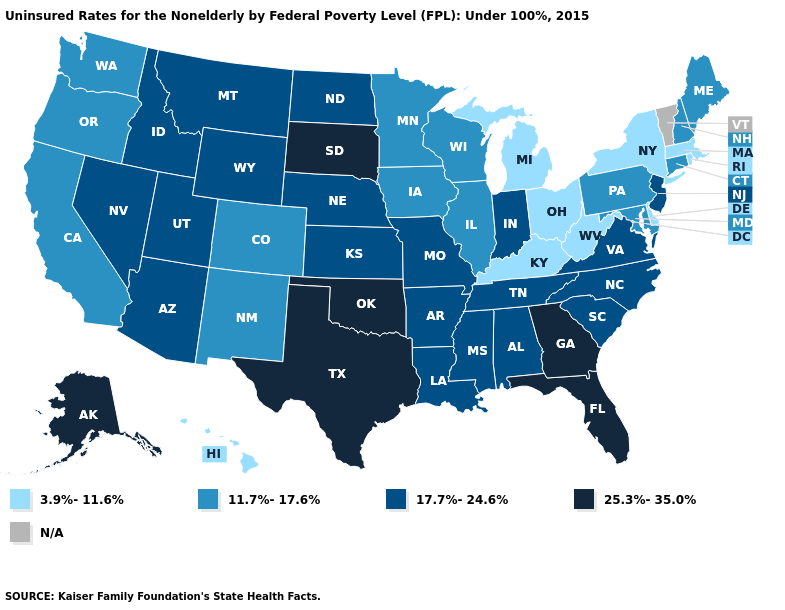Name the states that have a value in the range N/A?
Answer briefly. Vermont. Which states have the lowest value in the MidWest?
Answer briefly. Michigan, Ohio. Does Colorado have the lowest value in the USA?
Quick response, please. No. Which states have the lowest value in the USA?
Be succinct. Delaware, Hawaii, Kentucky, Massachusetts, Michigan, New York, Ohio, Rhode Island, West Virginia. Name the states that have a value in the range 3.9%-11.6%?
Answer briefly. Delaware, Hawaii, Kentucky, Massachusetts, Michigan, New York, Ohio, Rhode Island, West Virginia. Does Idaho have the lowest value in the USA?
Write a very short answer. No. What is the value of Georgia?
Quick response, please. 25.3%-35.0%. Name the states that have a value in the range 17.7%-24.6%?
Keep it brief. Alabama, Arizona, Arkansas, Idaho, Indiana, Kansas, Louisiana, Mississippi, Missouri, Montana, Nebraska, Nevada, New Jersey, North Carolina, North Dakota, South Carolina, Tennessee, Utah, Virginia, Wyoming. Which states have the highest value in the USA?
Write a very short answer. Alaska, Florida, Georgia, Oklahoma, South Dakota, Texas. Name the states that have a value in the range 11.7%-17.6%?
Give a very brief answer. California, Colorado, Connecticut, Illinois, Iowa, Maine, Maryland, Minnesota, New Hampshire, New Mexico, Oregon, Pennsylvania, Washington, Wisconsin. Name the states that have a value in the range 3.9%-11.6%?
Write a very short answer. Delaware, Hawaii, Kentucky, Massachusetts, Michigan, New York, Ohio, Rhode Island, West Virginia. Which states have the lowest value in the USA?
Keep it brief. Delaware, Hawaii, Kentucky, Massachusetts, Michigan, New York, Ohio, Rhode Island, West Virginia. Name the states that have a value in the range 25.3%-35.0%?
Be succinct. Alaska, Florida, Georgia, Oklahoma, South Dakota, Texas. 